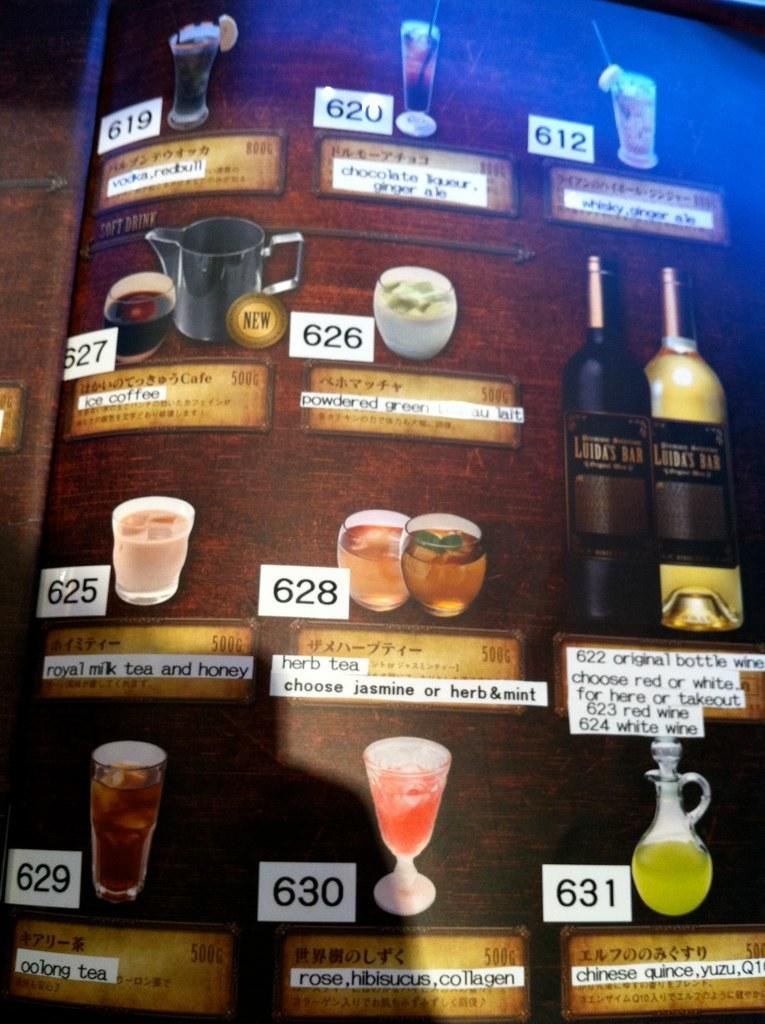Provide a one-sentence caption for the provided image. a drink menu board for things like Herb Tea and Ice Coffee. 